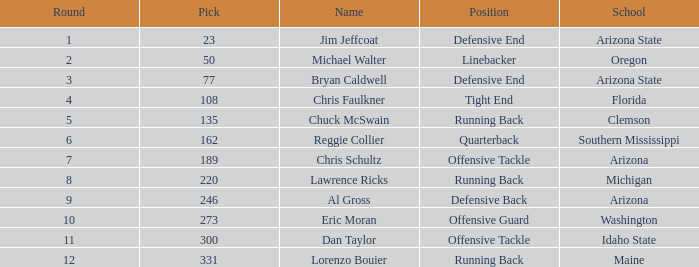What is the number of the pick for round 11? 300.0. 